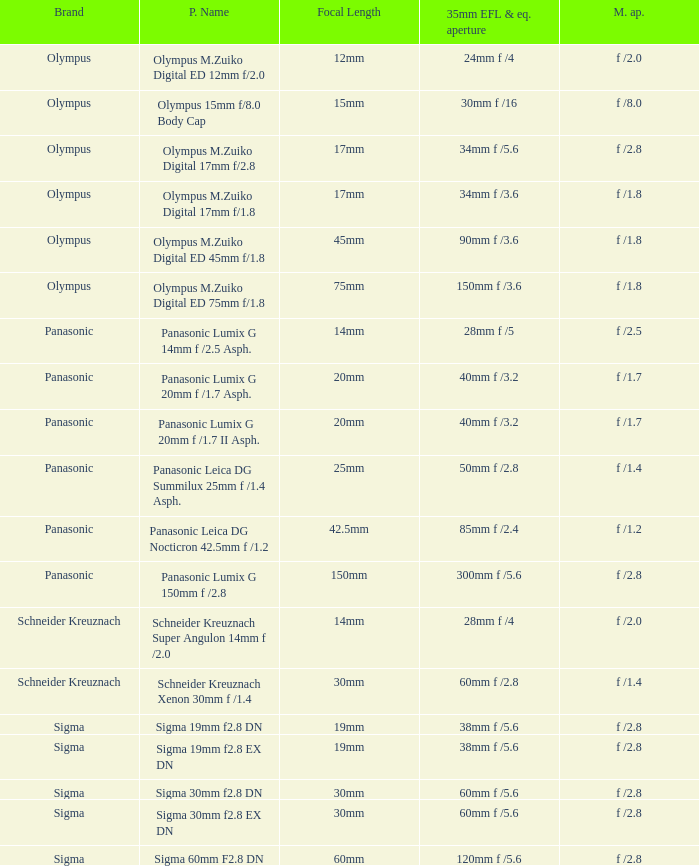What is the 35mm EFL and the equivalent aperture of the lens(es) with a maximum aperture of f /2.5? 28mm f /5. 